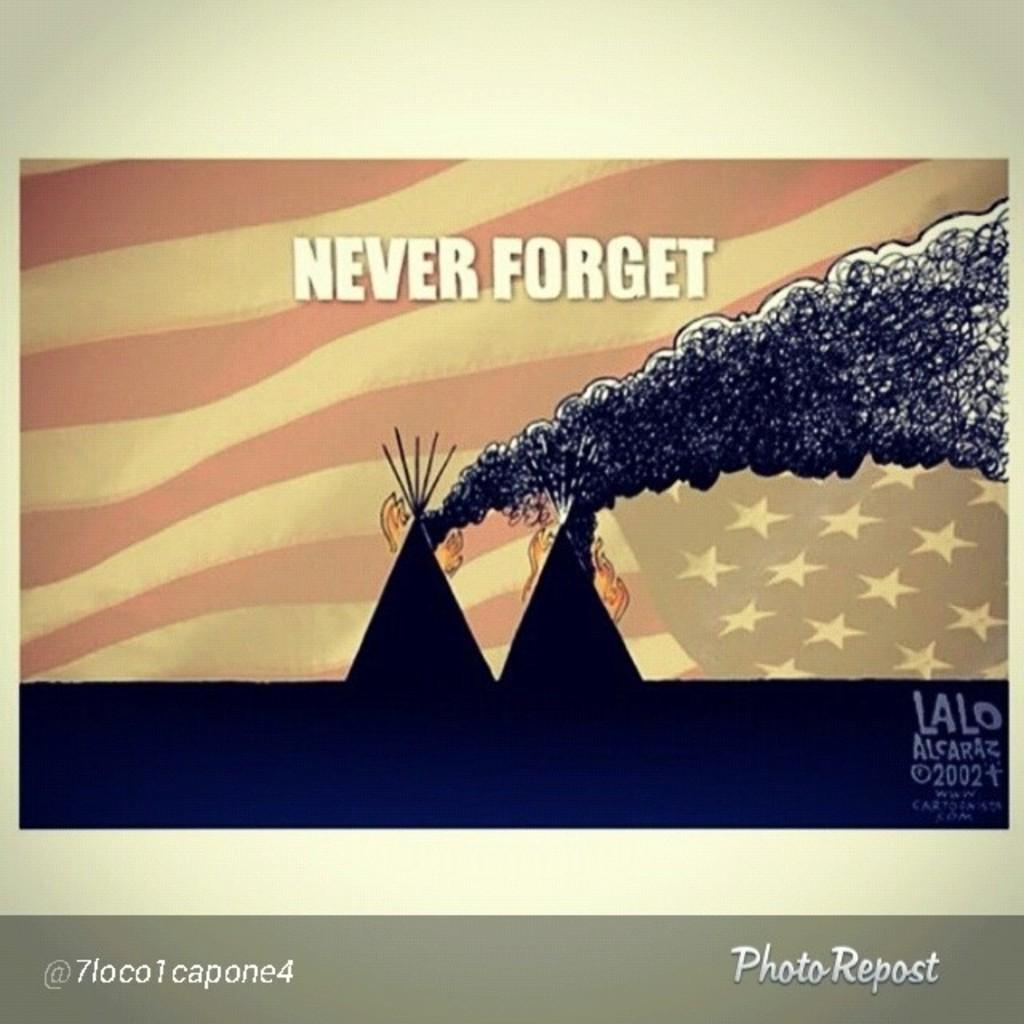What is present in the image that contains visual information? There is a poster in the image that contains images. What else can be found on the poster besides the images? There is text on the poster. Can you see a snail crawling on the poster in the image? There is no snail present on the poster in the image. What type of paper is the poster made of? The type of paper the poster is made of cannot be determined from the image. 